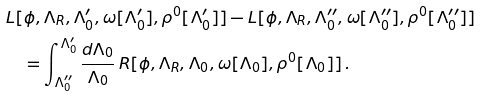<formula> <loc_0><loc_0><loc_500><loc_500>& L [ \phi , \Lambda _ { R } , \Lambda _ { 0 } ^ { \prime } , \omega [ \Lambda _ { 0 } ^ { \prime } ] , \rho ^ { 0 } [ \Lambda _ { 0 } ^ { \prime } ] ] - L [ \phi , \Lambda _ { R } , \Lambda _ { 0 } ^ { \prime \prime } , \omega [ \Lambda _ { 0 } ^ { \prime \prime } ] , \rho ^ { 0 } [ \Lambda _ { 0 } ^ { \prime \prime } ] ] \\ & \quad = \int _ { \Lambda _ { 0 } ^ { \prime \prime } } ^ { \Lambda _ { 0 } ^ { \prime } } \frac { d \Lambda _ { 0 } } { \Lambda _ { 0 } } \, R [ \phi , \Lambda _ { R } , \Lambda _ { 0 } , \omega [ \Lambda _ { 0 } ] , \rho ^ { 0 } [ \Lambda _ { 0 } ] ] \, .</formula> 